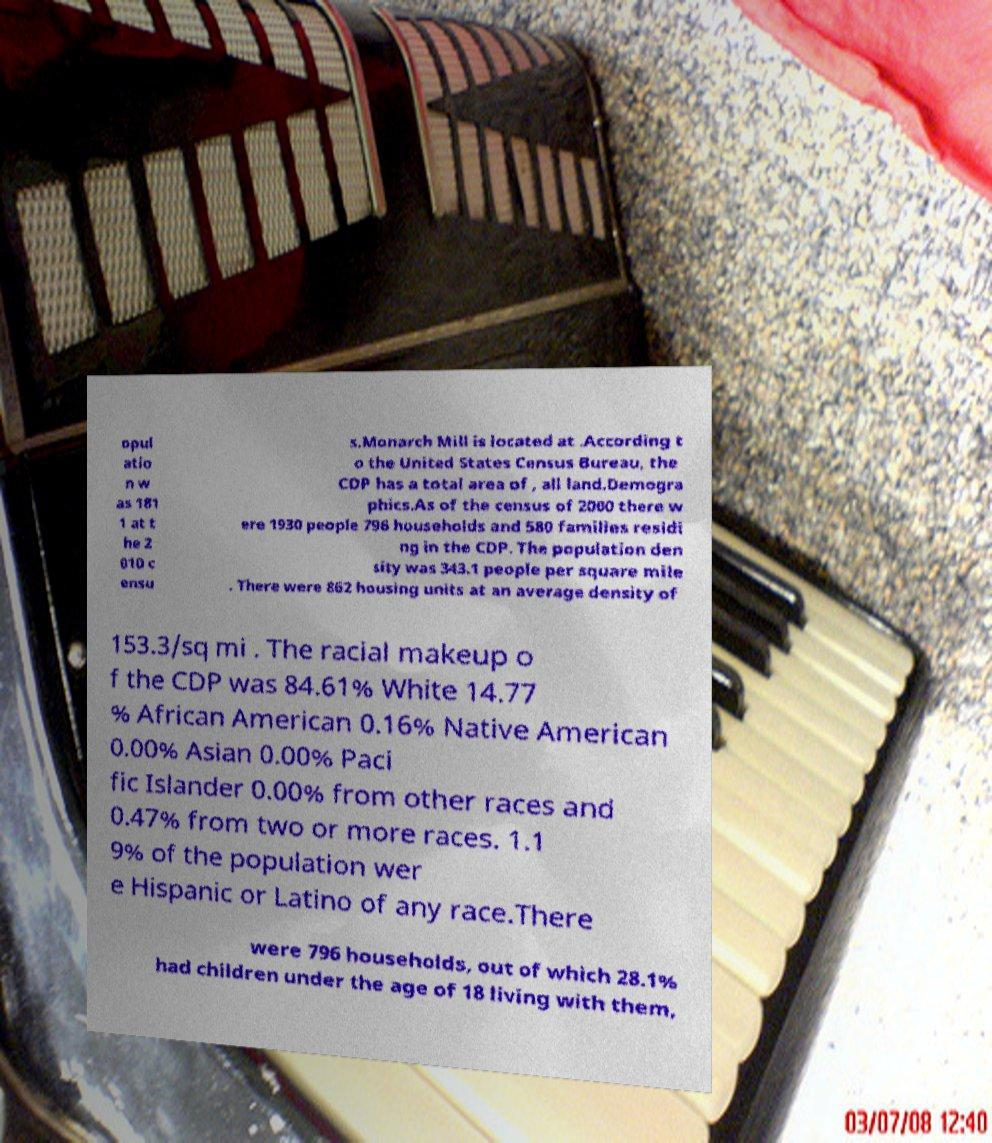Could you extract and type out the text from this image? opul atio n w as 181 1 at t he 2 010 c ensu s.Monarch Mill is located at .According t o the United States Census Bureau, the CDP has a total area of , all land.Demogra phics.As of the census of 2000 there w ere 1930 people 796 households and 580 families residi ng in the CDP. The population den sity was 343.1 people per square mile . There were 862 housing units at an average density of 153.3/sq mi . The racial makeup o f the CDP was 84.61% White 14.77 % African American 0.16% Native American 0.00% Asian 0.00% Paci fic Islander 0.00% from other races and 0.47% from two or more races. 1.1 9% of the population wer e Hispanic or Latino of any race.There were 796 households, out of which 28.1% had children under the age of 18 living with them, 